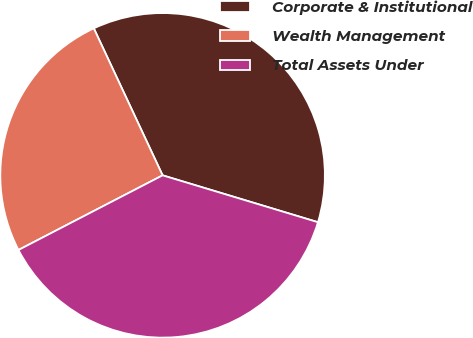Convert chart. <chart><loc_0><loc_0><loc_500><loc_500><pie_chart><fcel>Corporate & Institutional<fcel>Wealth Management<fcel>Total Assets Under<nl><fcel>36.63%<fcel>25.64%<fcel>37.73%<nl></chart> 